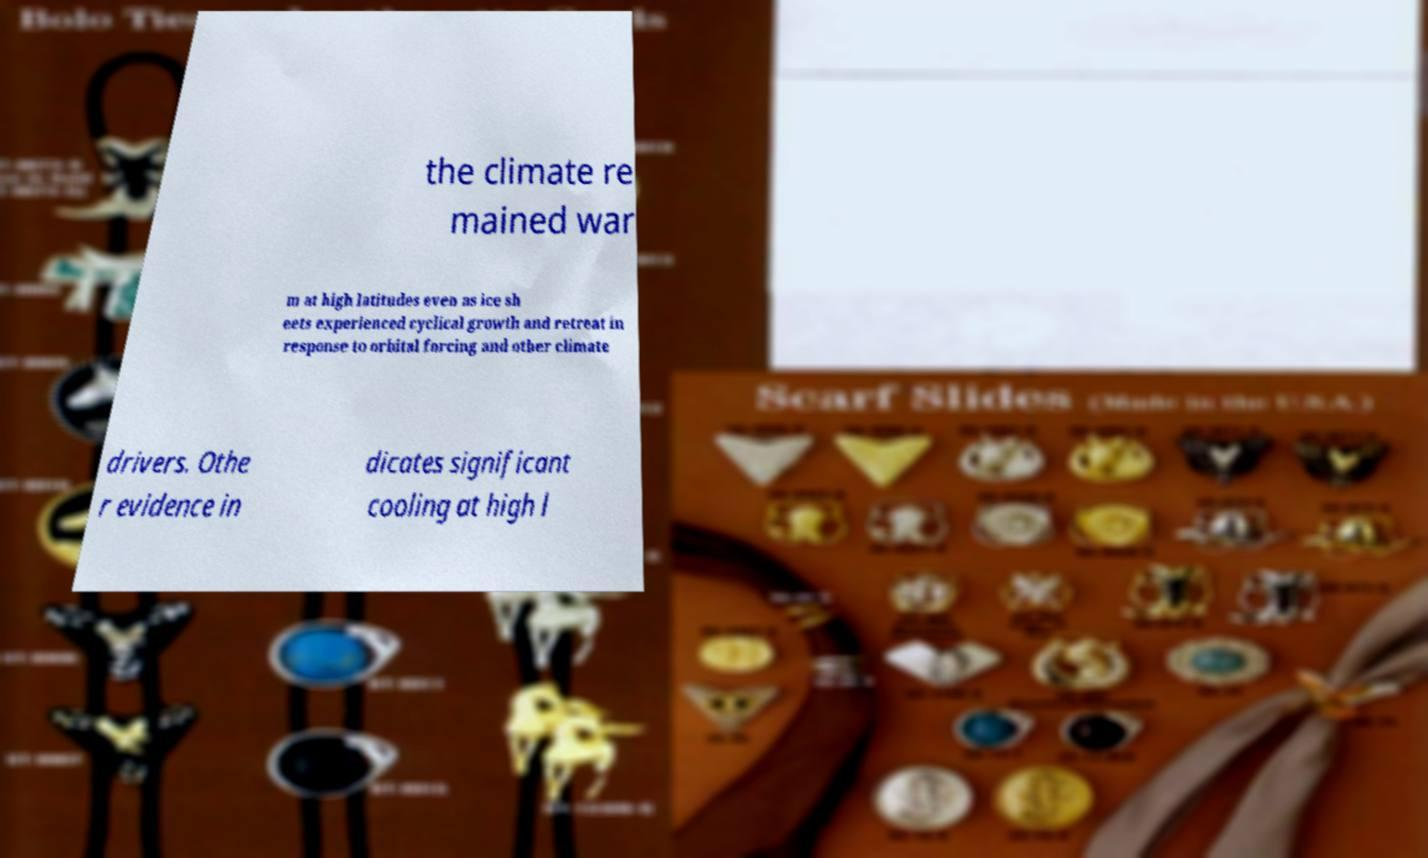I need the written content from this picture converted into text. Can you do that? the climate re mained war m at high latitudes even as ice sh eets experienced cyclical growth and retreat in response to orbital forcing and other climate drivers. Othe r evidence in dicates significant cooling at high l 